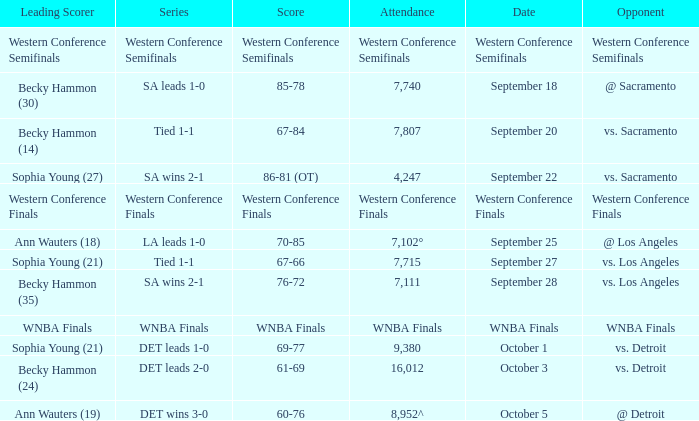Who is the leading scorer of the wnba finals series? WNBA Finals. 